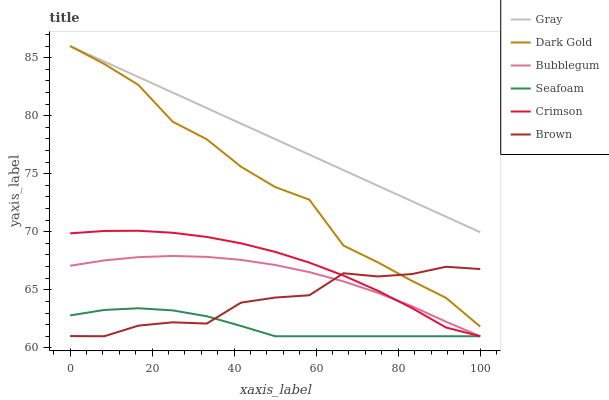Does Brown have the minimum area under the curve?
Answer yes or no. No. Does Brown have the maximum area under the curve?
Answer yes or no. No. Is Brown the smoothest?
Answer yes or no. No. Is Brown the roughest?
Answer yes or no. No. Does Dark Gold have the lowest value?
Answer yes or no. No. Does Brown have the highest value?
Answer yes or no. No. Is Brown less than Gray?
Answer yes or no. Yes. Is Gray greater than Brown?
Answer yes or no. Yes. Does Brown intersect Gray?
Answer yes or no. No. 